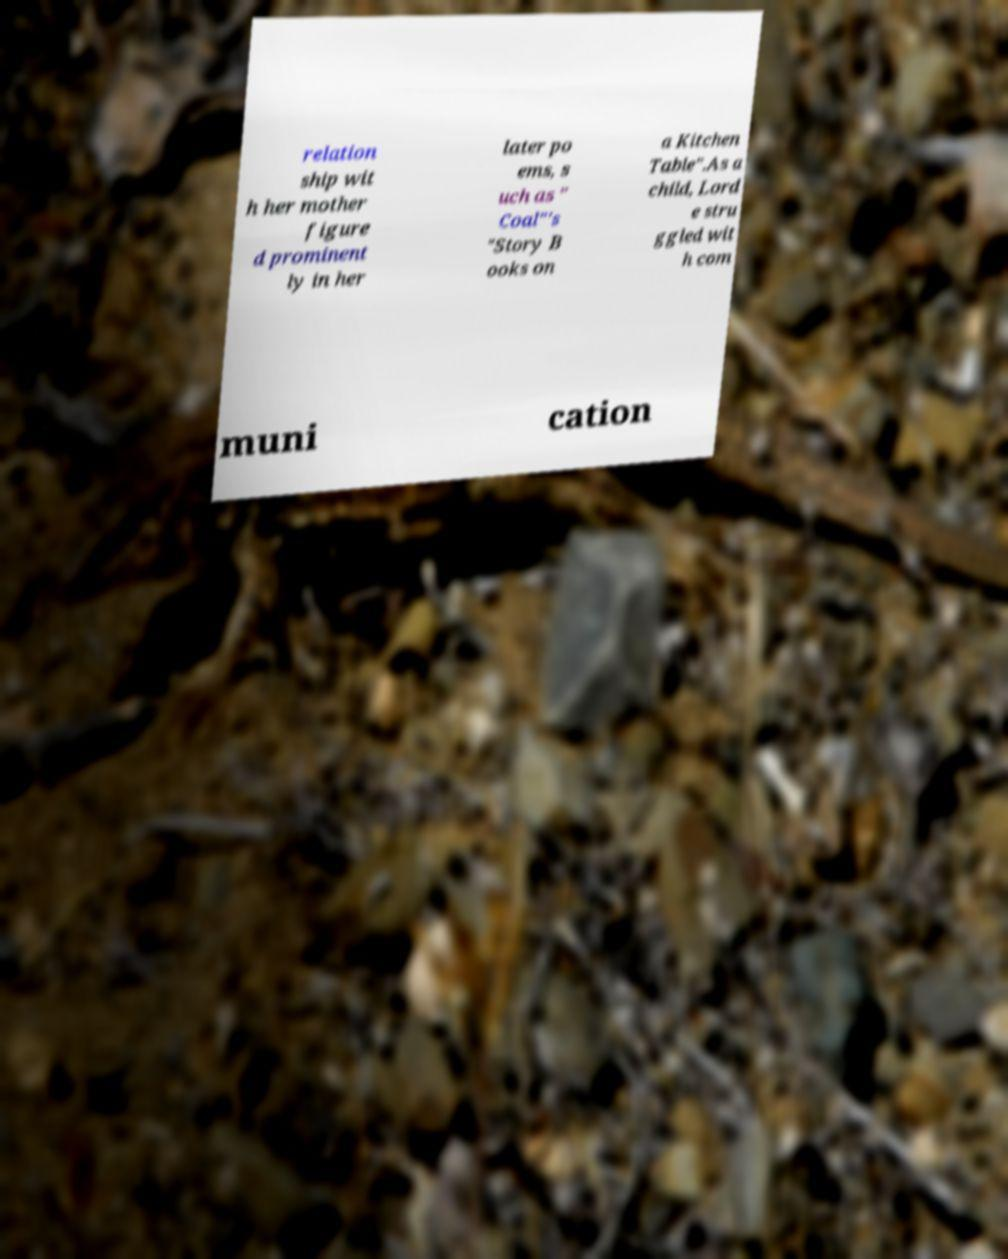Can you accurately transcribe the text from the provided image for me? relation ship wit h her mother figure d prominent ly in her later po ems, s uch as " Coal"'s "Story B ooks on a Kitchen Table".As a child, Lord e stru ggled wit h com muni cation 